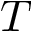Convert formula to latex. <formula><loc_0><loc_0><loc_500><loc_500>T</formula> 